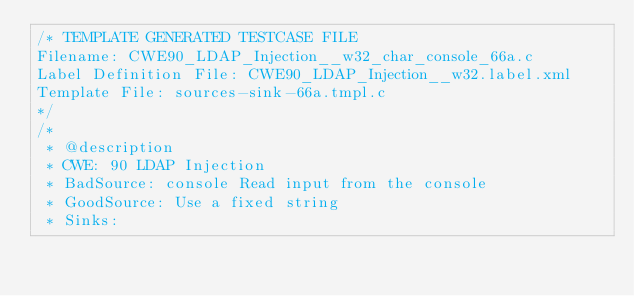Convert code to text. <code><loc_0><loc_0><loc_500><loc_500><_C_>/* TEMPLATE GENERATED TESTCASE FILE
Filename: CWE90_LDAP_Injection__w32_char_console_66a.c
Label Definition File: CWE90_LDAP_Injection__w32.label.xml
Template File: sources-sink-66a.tmpl.c
*/
/*
 * @description
 * CWE: 90 LDAP Injection
 * BadSource: console Read input from the console
 * GoodSource: Use a fixed string
 * Sinks:</code> 